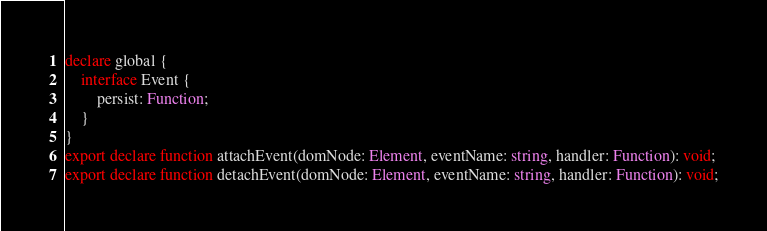Convert code to text. <code><loc_0><loc_0><loc_500><loc_500><_TypeScript_>declare global {
    interface Event {
        persist: Function;
    }
}
export declare function attachEvent(domNode: Element, eventName: string, handler: Function): void;
export declare function detachEvent(domNode: Element, eventName: string, handler: Function): void;
</code> 